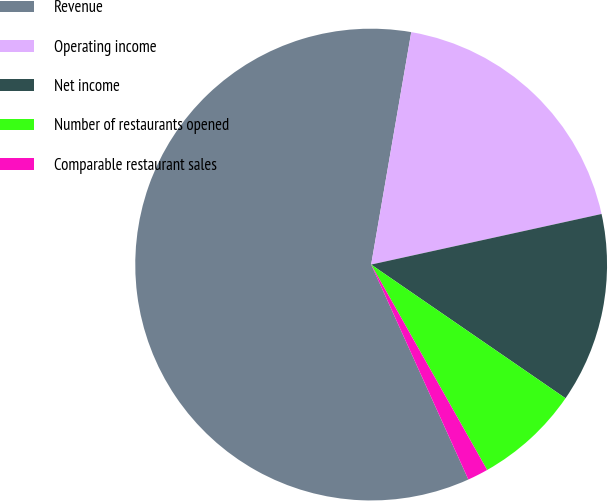<chart> <loc_0><loc_0><loc_500><loc_500><pie_chart><fcel>Revenue<fcel>Operating income<fcel>Net income<fcel>Number of restaurants opened<fcel>Comparable restaurant sales<nl><fcel>59.48%<fcel>18.84%<fcel>13.03%<fcel>7.23%<fcel>1.42%<nl></chart> 